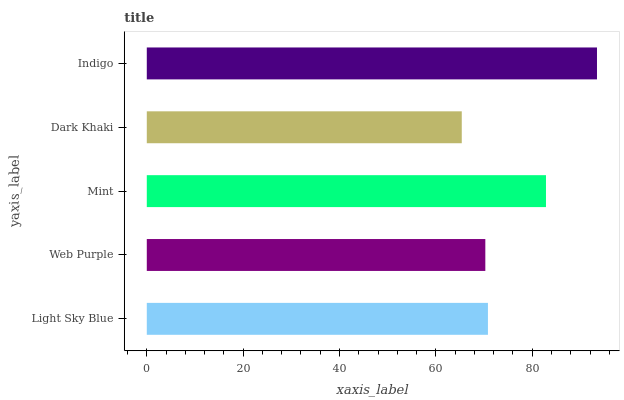Is Dark Khaki the minimum?
Answer yes or no. Yes. Is Indigo the maximum?
Answer yes or no. Yes. Is Web Purple the minimum?
Answer yes or no. No. Is Web Purple the maximum?
Answer yes or no. No. Is Light Sky Blue greater than Web Purple?
Answer yes or no. Yes. Is Web Purple less than Light Sky Blue?
Answer yes or no. Yes. Is Web Purple greater than Light Sky Blue?
Answer yes or no. No. Is Light Sky Blue less than Web Purple?
Answer yes or no. No. Is Light Sky Blue the high median?
Answer yes or no. Yes. Is Light Sky Blue the low median?
Answer yes or no. Yes. Is Web Purple the high median?
Answer yes or no. No. Is Dark Khaki the low median?
Answer yes or no. No. 